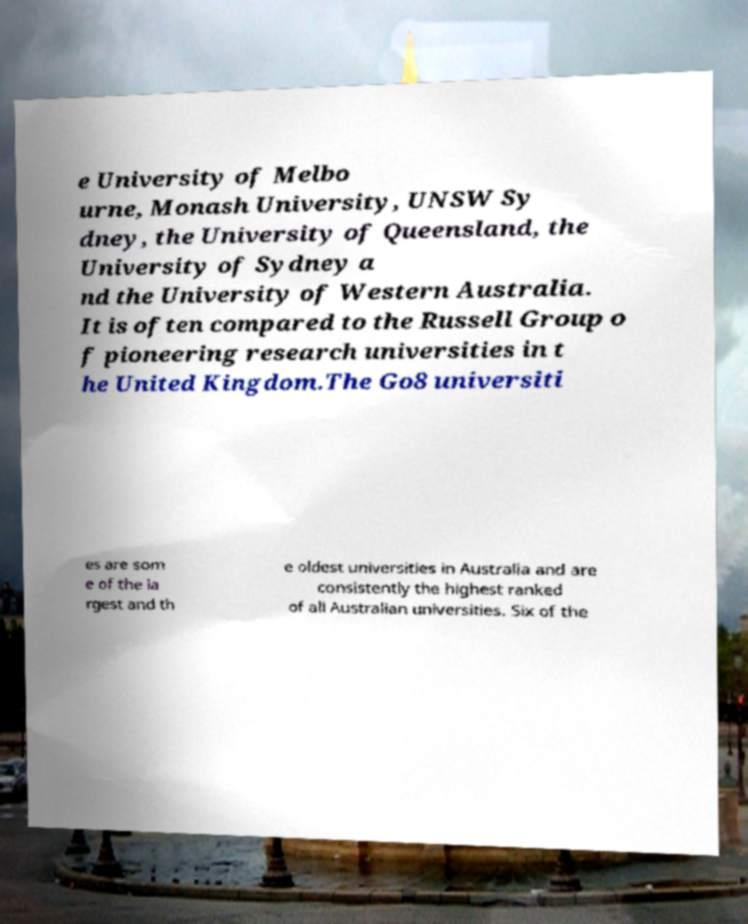Please identify and transcribe the text found in this image. e University of Melbo urne, Monash University, UNSW Sy dney, the University of Queensland, the University of Sydney a nd the University of Western Australia. It is often compared to the Russell Group o f pioneering research universities in t he United Kingdom.The Go8 universiti es are som e of the la rgest and th e oldest universities in Australia and are consistently the highest ranked of all Australian universities. Six of the 